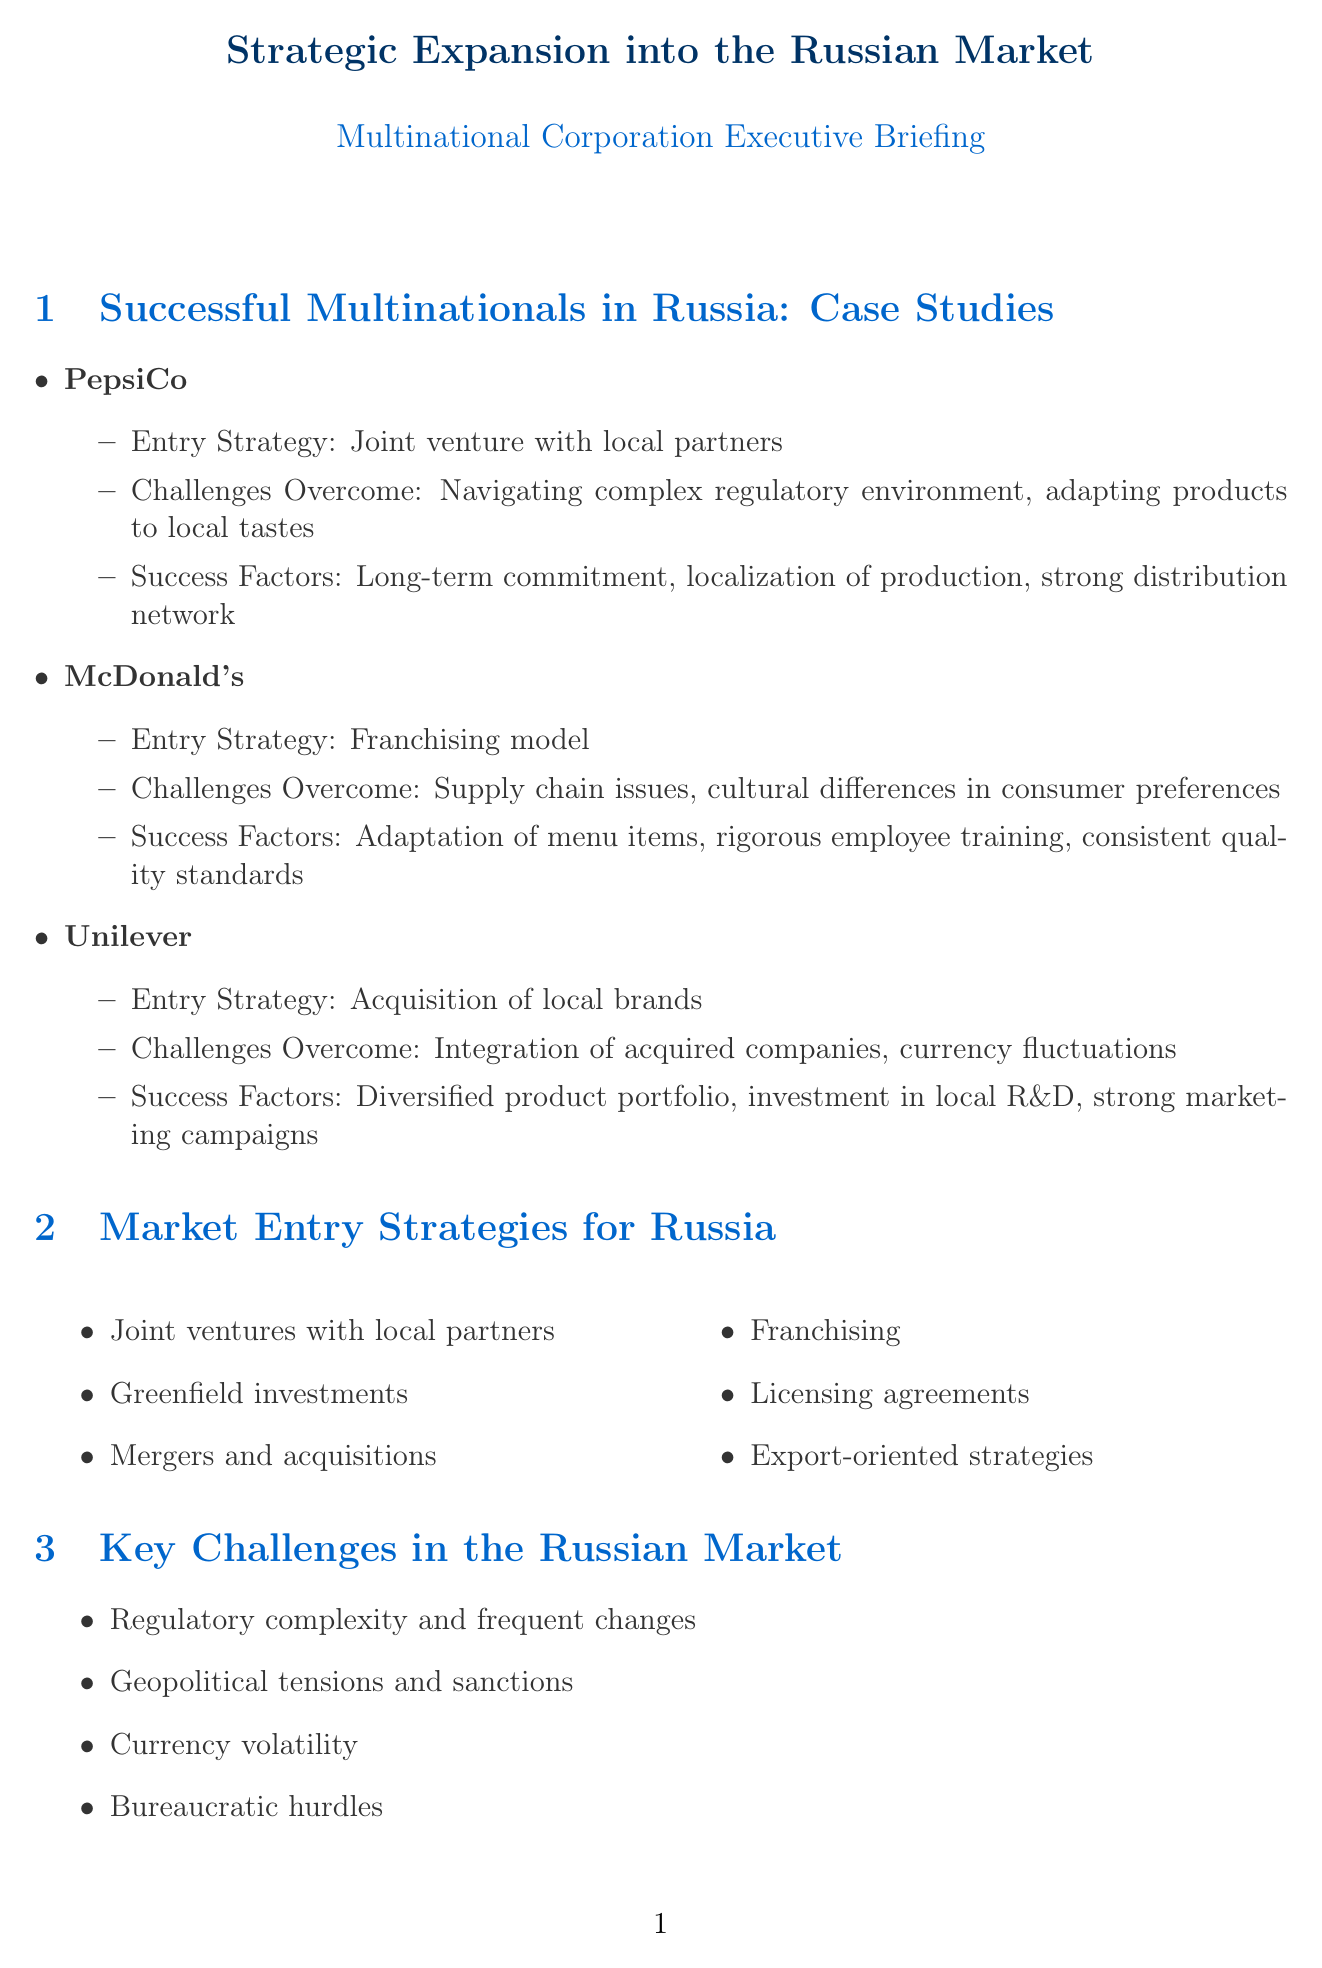what entry strategy did PepsiCo use in Russia? The entry strategy for PepsiCo in Russia was a joint venture with local partners.
Answer: Joint venture with local partners what challenge did McDonald's overcome in Russia? McDonald's overcame supply chain issues and cultural differences in consumer preferences.
Answer: Supply chain issues, cultural differences in consumer preferences what is one key challenge in the Russian market? Key challenges in the Russian market include regulatory complexity and frequent changes.
Answer: Regulatory complexity and frequent changes how many market entry strategies are listed in the document? The document lists six market entry strategies for Russia.
Answer: Six what is one financial consideration for expansion? One of the financial considerations for expansion is currency hedging strategies.
Answer: Currency hedging strategies which company used the franchising model for market entry? The company that used the franchising model for market entry was McDonald's.
Answer: McDonald's name one of the industry-specific opportunities in the healthcare sector. One of the industry-specific opportunities in the healthcare sector is pharmaceutical manufacturing.
Answer: Pharmaceutical manufacturing what is a success factor for Unilever in Russia? A success factor for Unilever in Russia is a diversified product portfolio.
Answer: Diversified product portfolio what did the document identify as a major issue related to compliance? The document identified anti-corruption measures as a major compliance issue.
Answer: Anti-corruption measures 